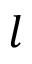<formula> <loc_0><loc_0><loc_500><loc_500>l</formula> 